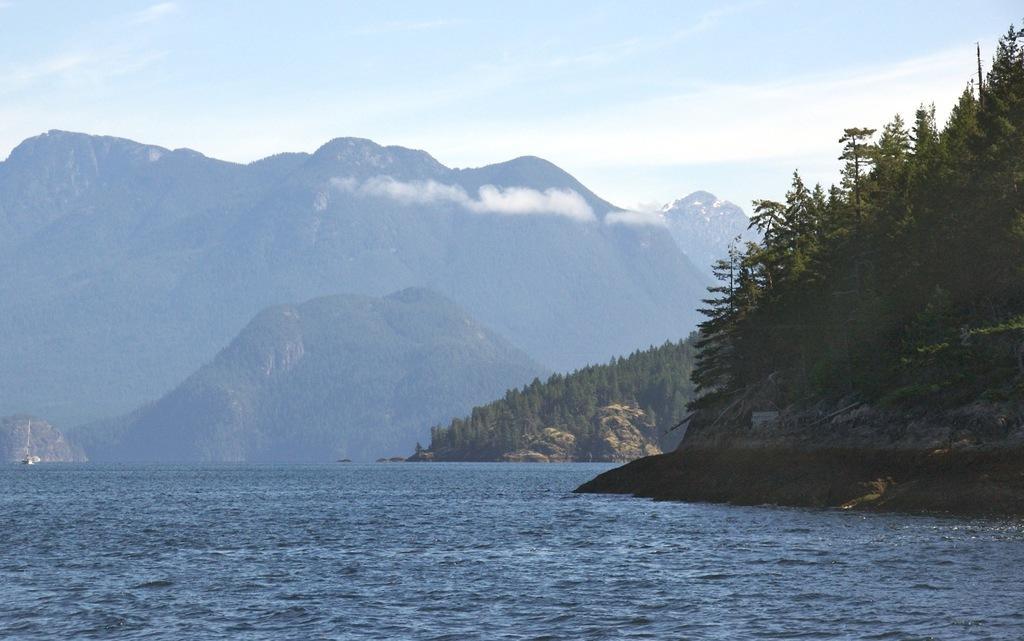Please provide a concise description of this image. In this picture we can see water. There are trees, mountains and the sky. 